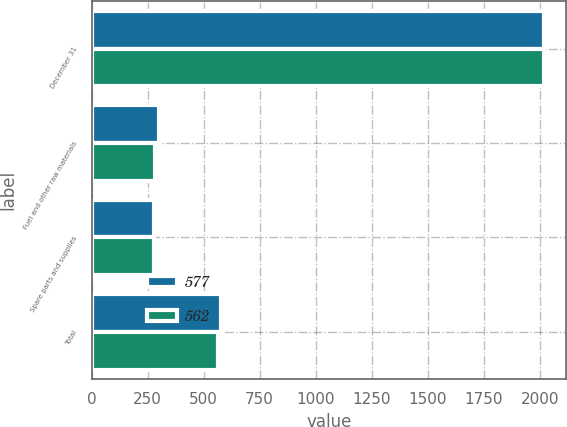Convert chart. <chart><loc_0><loc_0><loc_500><loc_500><stacked_bar_chart><ecel><fcel>December 31<fcel>Fuel and other raw materials<fcel>Spare parts and supplies<fcel>Total<nl><fcel>577<fcel>2018<fcel>300<fcel>277<fcel>577<nl><fcel>562<fcel>2017<fcel>284<fcel>278<fcel>562<nl></chart> 